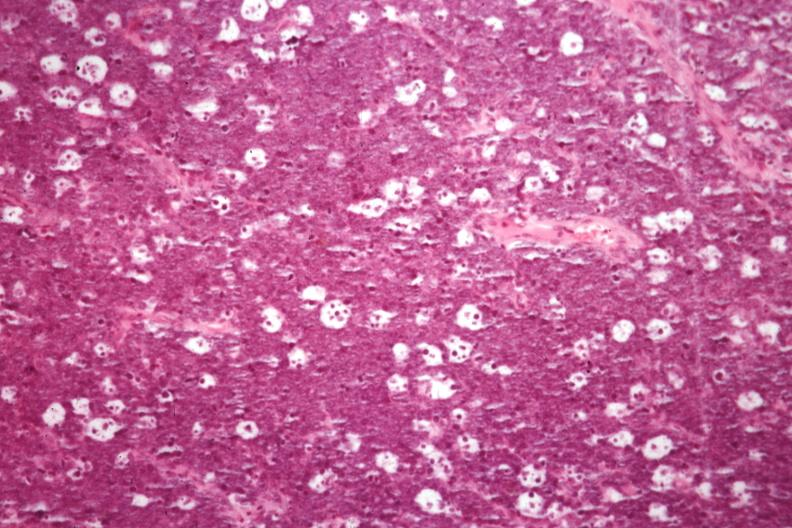does this image show excellent for starry sky appearance but not the best histology source?
Answer the question using a single word or phrase. Yes 